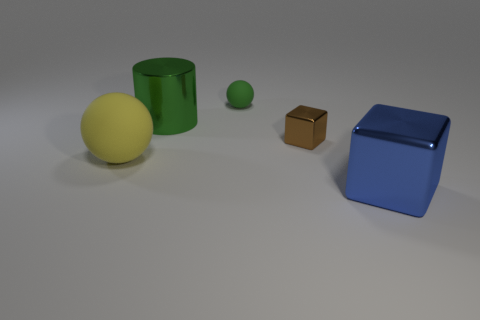Are there any brown blocks of the same size as the yellow rubber object? No, the only brown object present is a small cube, which is significantly smaller than the yellow spherical rubber object. 